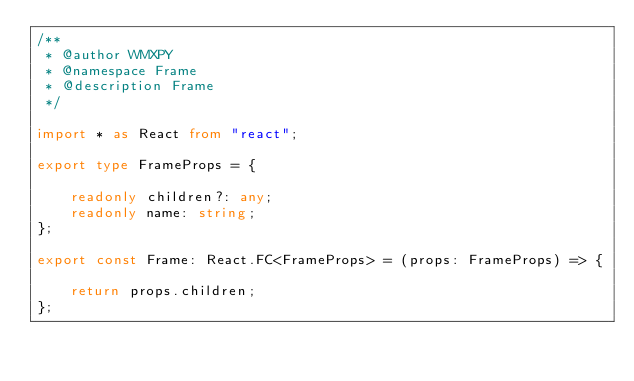Convert code to text. <code><loc_0><loc_0><loc_500><loc_500><_TypeScript_>/**
 * @author WMXPY
 * @namespace Frame
 * @description Frame
 */

import * as React from "react";

export type FrameProps = {

    readonly children?: any;
    readonly name: string;
};

export const Frame: React.FC<FrameProps> = (props: FrameProps) => {

    return props.children;
};
</code> 